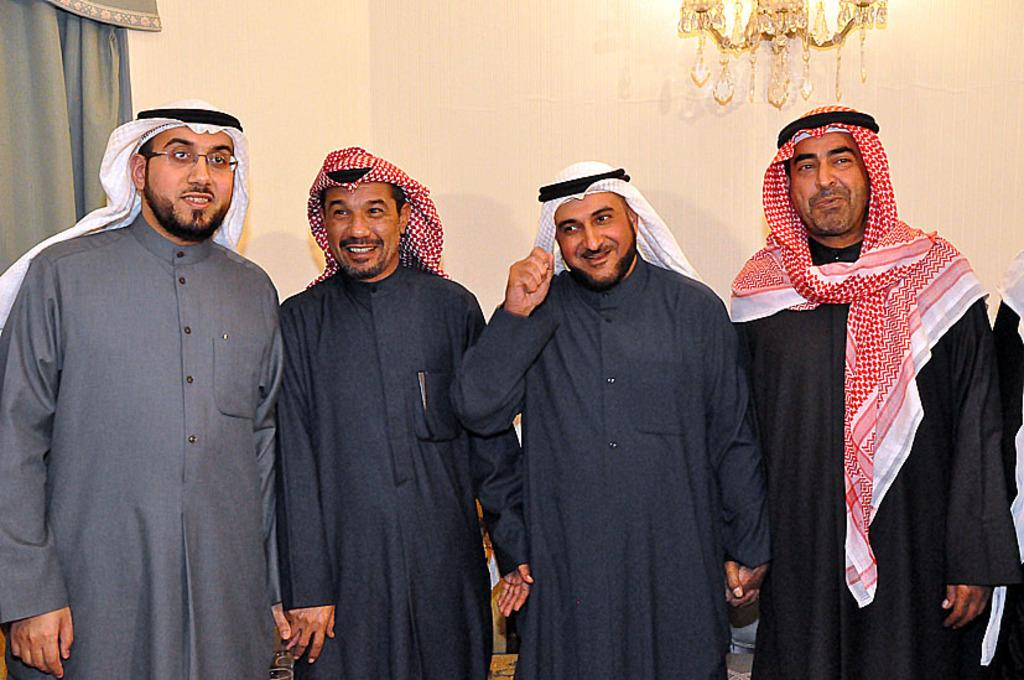How many people are in the image? There are four persons standing in the image. What are the persons wearing on their heads? The persons are wearing a cloth on their head. Can you describe any objects in the image? Yes, there is a jhoomer in the right top corner of the image and a curtain in the left top corner of the image. How many tomatoes are on the floor in the image? There are no tomatoes present in the image. Did the persons feel an earthquake while standing in the image? There is no indication of an earthquake or any related effects in the image. 